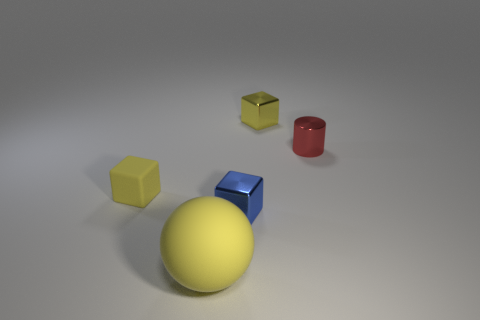How would you describe the spatial arrangement of the objects in the image? The objects are positioned in an asymmetrical arrangement. The large yellow ball is near the center, with a smaller blue cube directly to its right. In front of these, there's a smaller yellow cube and a red cylinder in the foreground. A tiny yellow cube is in front of the red cylinder. 